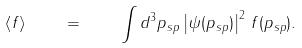<formula> <loc_0><loc_0><loc_500><loc_500>\left \langle f \right \rangle \quad = \quad \int d ^ { 3 } { p } _ { s p } \left | \psi ( { p } _ { s p } ) \right | ^ { 2 } \, f ( { p } _ { s p } ) .</formula> 